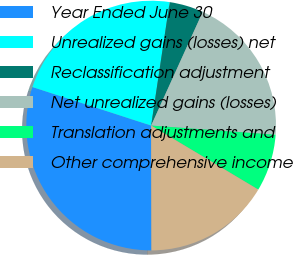Convert chart to OTSL. <chart><loc_0><loc_0><loc_500><loc_500><pie_chart><fcel>Year Ended June 30<fcel>Unrealized gains (losses) net<fcel>Reclassification adjustment<fcel>Net unrealized gains (losses)<fcel>Translation adjustments and<fcel>Other comprehensive income<nl><fcel>30.03%<fcel>22.38%<fcel>4.41%<fcel>19.39%<fcel>7.4%<fcel>16.39%<nl></chart> 